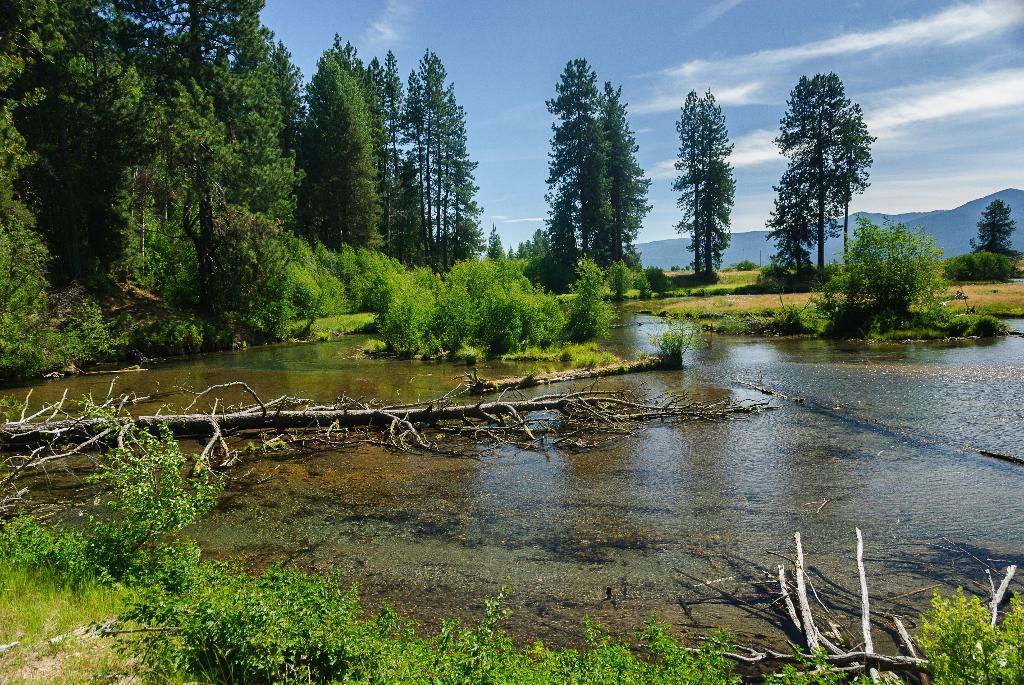In one or two sentences, can you explain what this image depicts? In this image, we can see some trees beside the lake. There are some plants at the bottom of the image. There is a sky at the top of the image. 